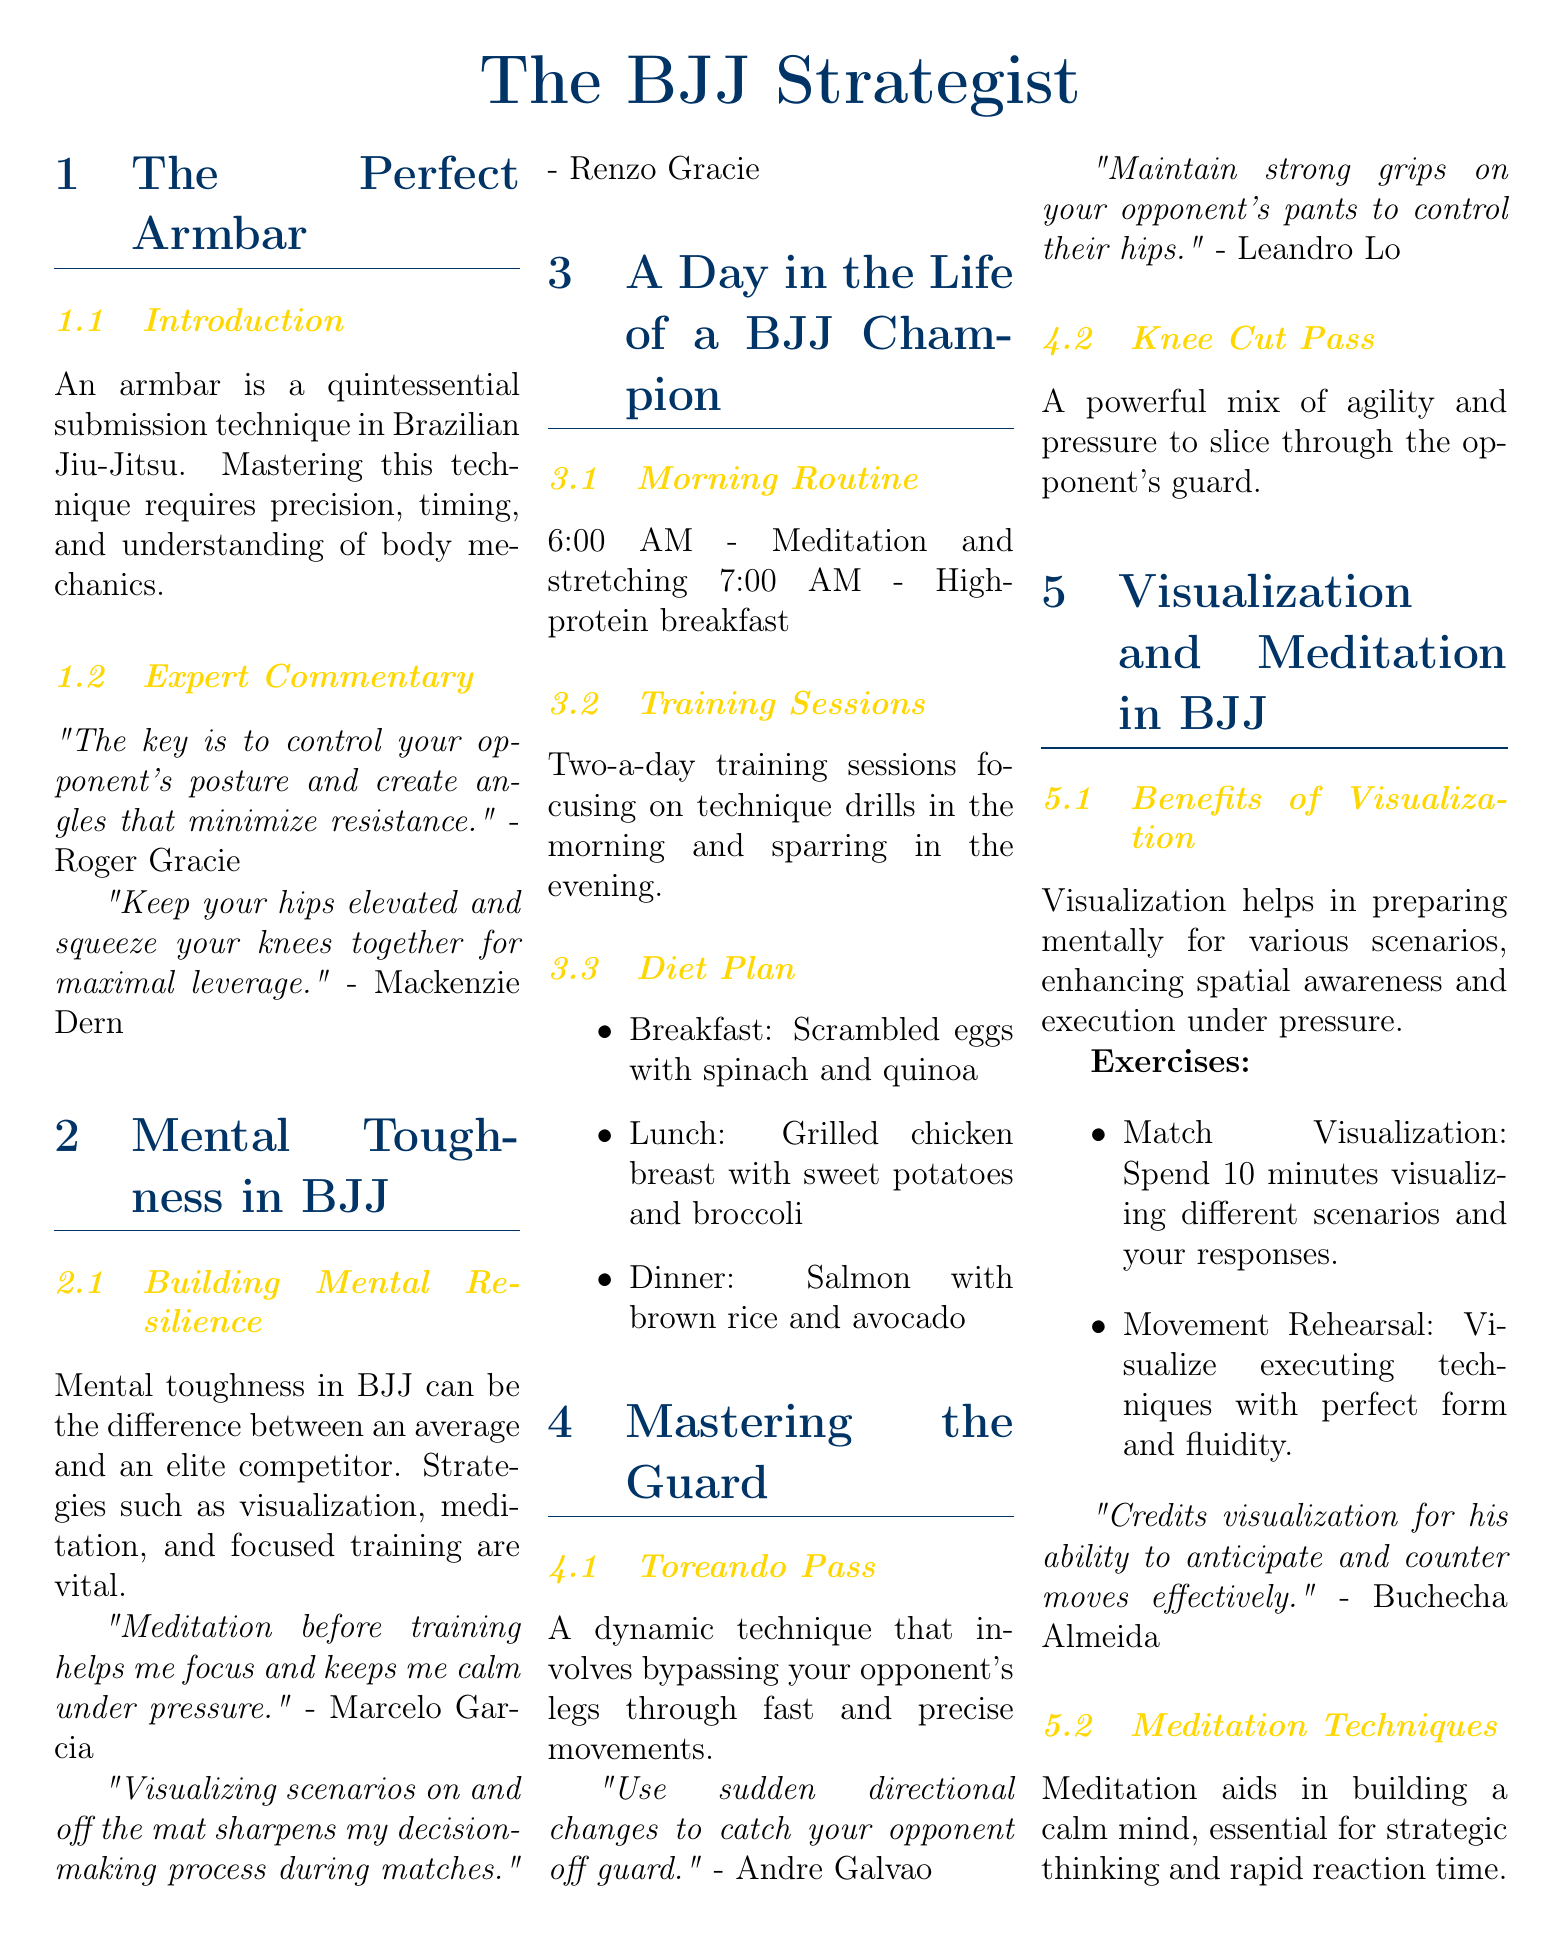What is the title of the article? The title of the article is prominently displayed at the beginning and introduces the main topic of the document.
Answer: The BJJ Strategist Who provided expert commentary on the armbar technique? The document includes quotes from notable BJJ athletes sharing their insights, specifically on the armbar.
Answer: Roger Gracie and Mackenzie Dern What is one of the morning activities of a BJJ champion? The document outlines a champion's daily routine, which includes various activities.
Answer: Meditation and stretching What type of pass is mentioned as a dynamic technique in mastering the guard? The document describes specific guard passing techniques, highlighting noteworthy moves.
Answer: Toreando Pass Which athlete credits visualization for anticipating counter moves? The document attributes specific mental strategies to elite competitors, highlighting their perspectives.
Answer: Buchecha Almeida What dietary item is included in the champion's lunch? The document details the day-to-day diet of a BJJ champion, including specific food items.
Answer: Grilled chicken breast with sweet potatoes and broccoli What is a key strategy for building mental resilience in BJJ? The document discusses various mental preparation strategies used by top competitors in BJJ.
Answer: Visualization, meditation, and focused training What type of meditation is recommended for calmness under pressure? The document emphasizes the role of meditation in preparing mentally for competitions.
Answer: Meditation techniques What benefit does visualization provide according to the document? The document outlines the advantages of visualization in relation to competitive performance.
Answer: Enhances spatial awareness and execution under pressure 